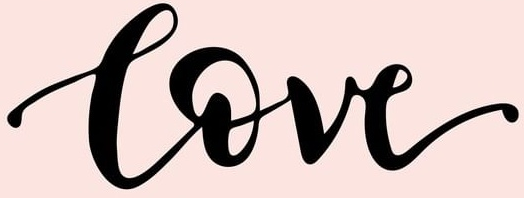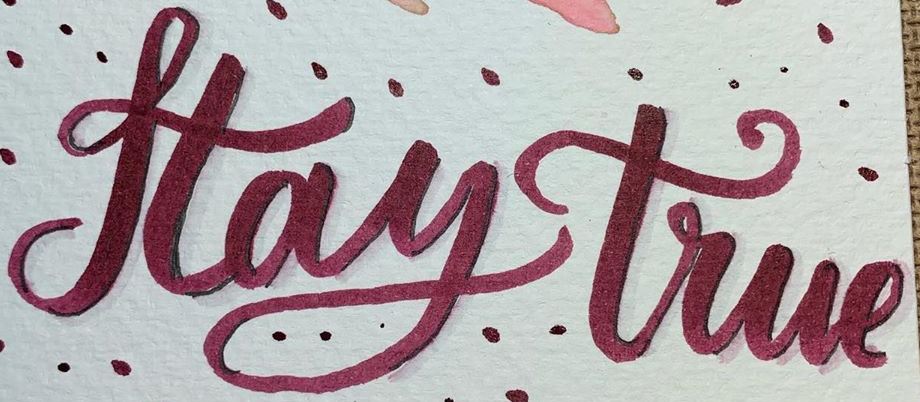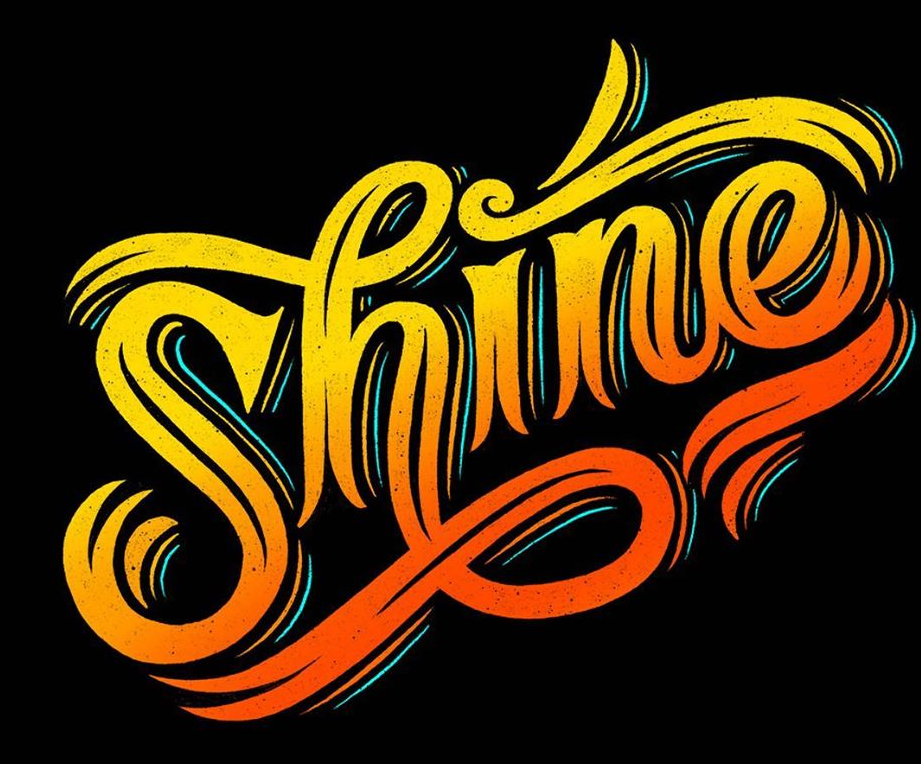What words can you see in these images in sequence, separated by a semicolon? Love; Haytrue; Shine 